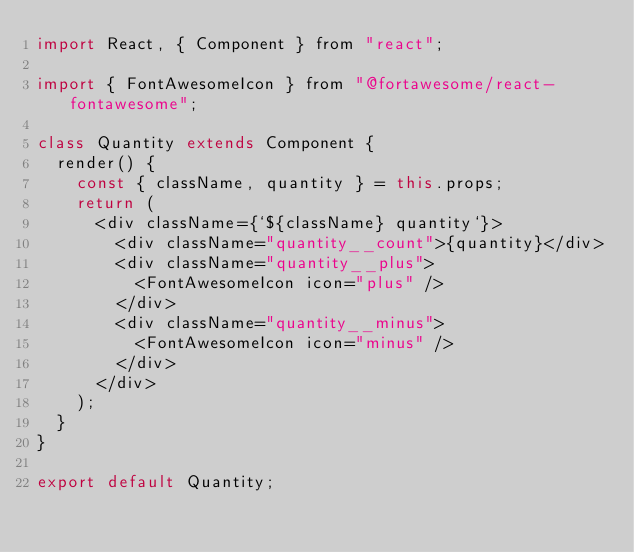Convert code to text. <code><loc_0><loc_0><loc_500><loc_500><_JavaScript_>import React, { Component } from "react";

import { FontAwesomeIcon } from "@fortawesome/react-fontawesome";

class Quantity extends Component {
  render() {
    const { className, quantity } = this.props;
    return (
      <div className={`${className} quantity`}>
        <div className="quantity__count">{quantity}</div>
        <div className="quantity__plus">
          <FontAwesomeIcon icon="plus" />
        </div>
        <div className="quantity__minus">
          <FontAwesomeIcon icon="minus" />
        </div>
      </div>
    );
  }
}

export default Quantity;
</code> 